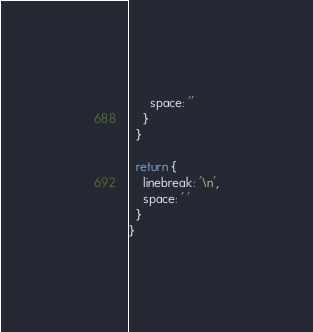<code> <loc_0><loc_0><loc_500><loc_500><_JavaScript_>      space: ''
    }
  }

  return {
    linebreak: '\n',
    space: ' '
  }
}
</code> 